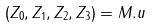<formula> <loc_0><loc_0><loc_500><loc_500>( Z _ { 0 } , Z _ { 1 } , Z _ { 2 } , Z _ { 3 } ) = M . u</formula> 